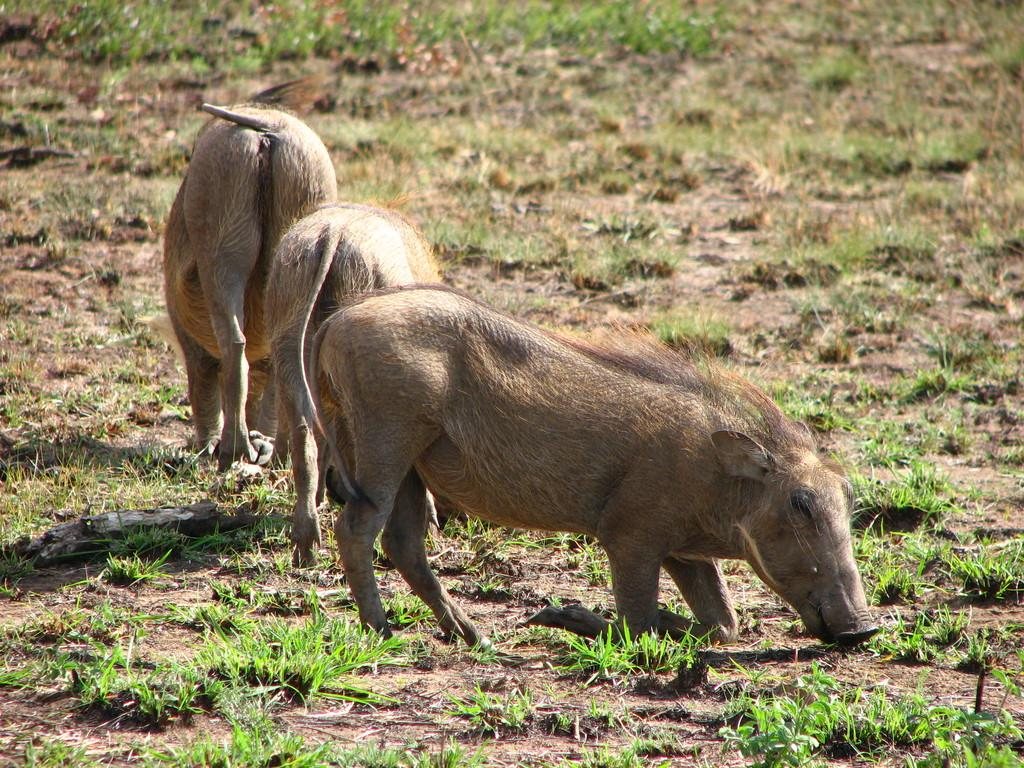What animals are present on the ground in the image? There are three pigs on the ground in the image. What object can be seen on the left side of the image? There is a stick on the left side of the image. What type of vegetation is visible on the ground? There is grass on the ground in the image. What type of crack is visible on the doctor's forehead in the image? There is no doctor or crack present in the image. What type of corn is being fed to the pigs in the image? There is no corn visible in the image; only the three pigs and a stick are present. 